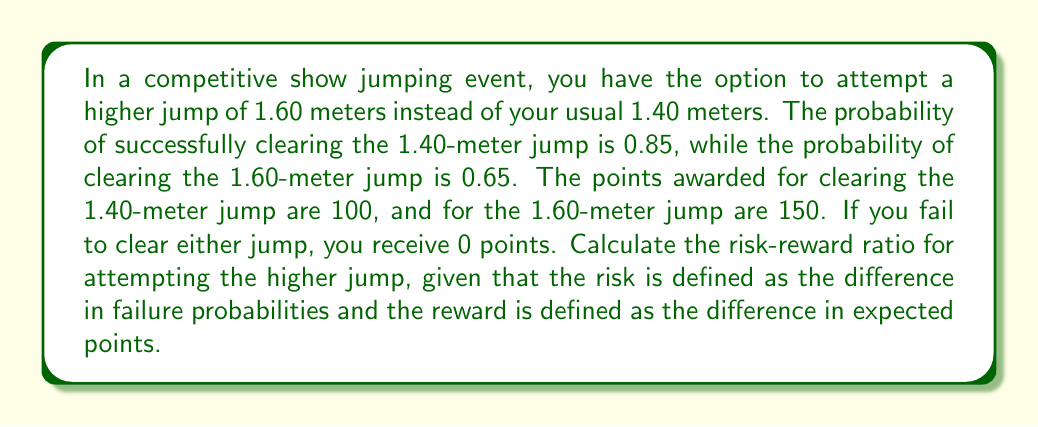What is the answer to this math problem? To calculate the risk-reward ratio, we need to follow these steps:

1. Calculate the probability of failure for each jump:
   - For 1.40m: $P(\text{failure})_{1.40} = 1 - 0.85 = 0.15$
   - For 1.60m: $P(\text{failure})_{1.60} = 1 - 0.65 = 0.35$

2. Calculate the risk (difference in failure probabilities):
   $\text{Risk} = P(\text{failure})_{1.60} - P(\text{failure})_{1.40} = 0.35 - 0.15 = 0.20$

3. Calculate the expected points for each jump:
   - For 1.40m: $E(\text{points})_{1.40} = 100 \times 0.85 + 0 \times 0.15 = 85$
   - For 1.60m: $E(\text{points})_{1.60} = 150 \times 0.65 + 0 \times 0.35 = 97.5$

4. Calculate the reward (difference in expected points):
   $\text{Reward} = E(\text{points})_{1.60} - E(\text{points})_{1.40} = 97.5 - 85 = 12.5$

5. Calculate the risk-reward ratio:
   $$\text{Risk-Reward Ratio} = \frac{\text{Risk}}{\text{Reward}} = \frac{0.20}{12.5} = 0.016$$

The risk-reward ratio is 0.016, which means for every unit of reward (expected points gained), you're taking on 0.016 units of risk (increase in failure probability).
Answer: The risk-reward ratio for attempting the higher jump is 0.016. 